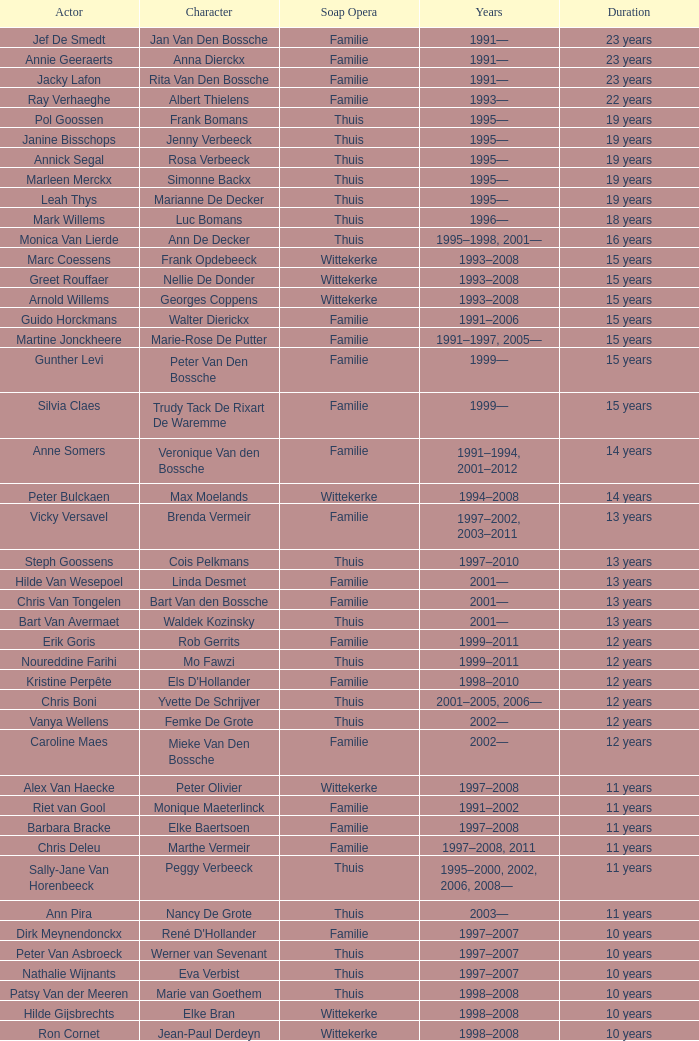What actor plays Marie-Rose De Putter? Martine Jonckheere. 